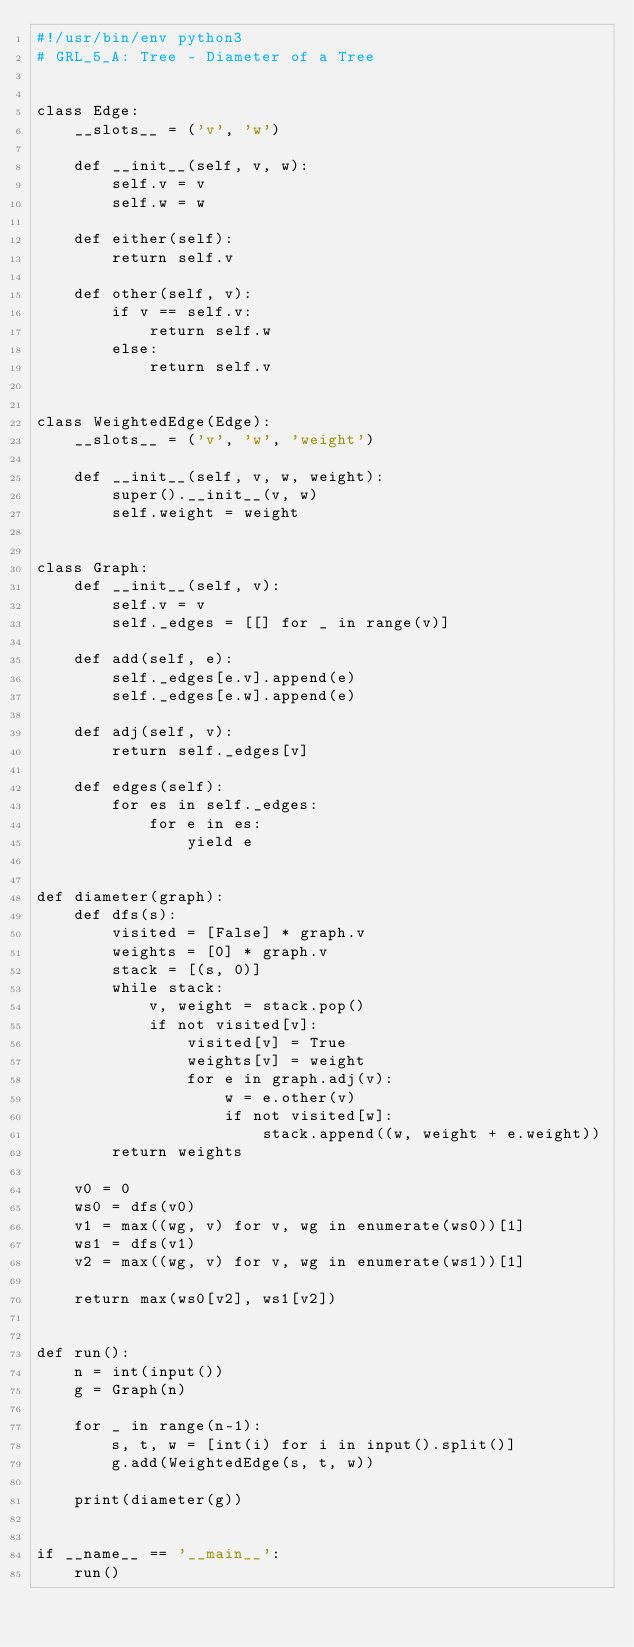<code> <loc_0><loc_0><loc_500><loc_500><_Python_>#!/usr/bin/env python3
# GRL_5_A: Tree - Diameter of a Tree


class Edge:
    __slots__ = ('v', 'w')

    def __init__(self, v, w):
        self.v = v
        self.w = w

    def either(self):
        return self.v

    def other(self, v):
        if v == self.v:
            return self.w
        else:
            return self.v


class WeightedEdge(Edge):
    __slots__ = ('v', 'w', 'weight')

    def __init__(self, v, w, weight):
        super().__init__(v, w)
        self.weight = weight


class Graph:
    def __init__(self, v):
        self.v = v
        self._edges = [[] for _ in range(v)]

    def add(self, e):
        self._edges[e.v].append(e)
        self._edges[e.w].append(e)

    def adj(self, v):
        return self._edges[v]

    def edges(self):
        for es in self._edges:
            for e in es:
                yield e


def diameter(graph):
    def dfs(s):
        visited = [False] * graph.v
        weights = [0] * graph.v
        stack = [(s, 0)]
        while stack:
            v, weight = stack.pop()
            if not visited[v]:
                visited[v] = True
                weights[v] = weight
                for e in graph.adj(v):
                    w = e.other(v)
                    if not visited[w]:
                        stack.append((w, weight + e.weight))
        return weights

    v0 = 0
    ws0 = dfs(v0)
    v1 = max((wg, v) for v, wg in enumerate(ws0))[1]
    ws1 = dfs(v1)
    v2 = max((wg, v) for v, wg in enumerate(ws1))[1]

    return max(ws0[v2], ws1[v2])


def run():
    n = int(input())
    g = Graph(n)

    for _ in range(n-1):
        s, t, w = [int(i) for i in input().split()]
        g.add(WeightedEdge(s, t, w))

    print(diameter(g))


if __name__ == '__main__':
    run()

</code> 